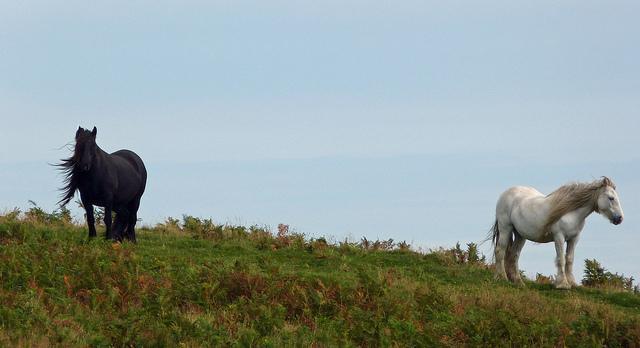How many animals are there?
Give a very brief answer. 2. How many animals are roaming?
Give a very brief answer. 2. How many horses are in the field?
Give a very brief answer. 2. How many horse ears are in the image?
Give a very brief answer. 4. How many horses are in the photo?
Give a very brief answer. 2. 